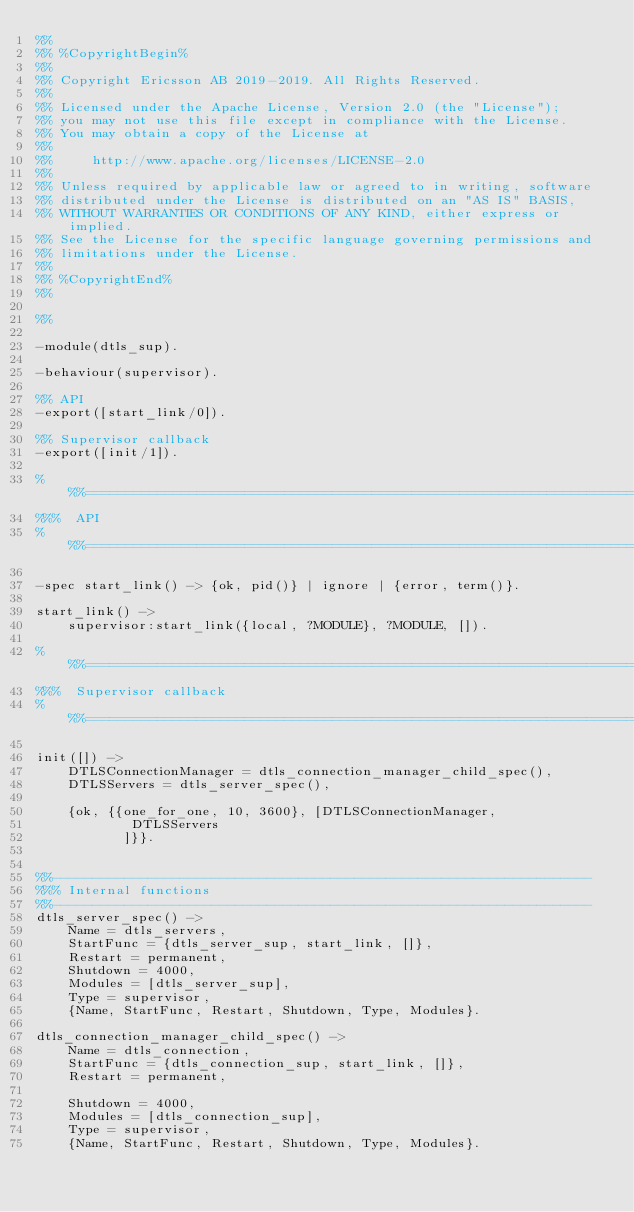Convert code to text. <code><loc_0><loc_0><loc_500><loc_500><_Erlang_>%%
%% %CopyrightBegin%
%%
%% Copyright Ericsson AB 2019-2019. All Rights Reserved.
%%
%% Licensed under the Apache License, Version 2.0 (the "License");
%% you may not use this file except in compliance with the License.
%% You may obtain a copy of the License at
%%
%%     http://www.apache.org/licenses/LICENSE-2.0
%%
%% Unless required by applicable law or agreed to in writing, software
%% distributed under the License is distributed on an "AS IS" BASIS,
%% WITHOUT WARRANTIES OR CONDITIONS OF ANY KIND, either express or implied.
%% See the License for the specific language governing permissions and
%% limitations under the License.
%%
%% %CopyrightEnd%
%%

%%

-module(dtls_sup).

-behaviour(supervisor).

%% API
-export([start_link/0]).

%% Supervisor callback
-export([init/1]).

%%%=========================================================================
%%%  API
%%%=========================================================================

-spec start_link() -> {ok, pid()} | ignore | {error, term()}.
			
start_link() ->
    supervisor:start_link({local, ?MODULE}, ?MODULE, []).

%%%=========================================================================
%%%  Supervisor callback
%%%=========================================================================

init([]) ->    
    DTLSConnectionManager = dtls_connection_manager_child_spec(),
    DTLSServers = dtls_server_spec(),
    
    {ok, {{one_for_one, 10, 3600}, [DTLSConnectionManager, 
				    DTLSServers
				   ]}}.

    
%%--------------------------------------------------------------------
%%% Internal functions
%%--------------------------------------------------------------------
dtls_server_spec() ->
    Name = dtls_servers,
    StartFunc = {dtls_server_sup, start_link, []},
    Restart = permanent,
    Shutdown = 4000,
    Modules = [dtls_server_sup],
    Type = supervisor,
    {Name, StartFunc, Restart, Shutdown, Type, Modules}.

dtls_connection_manager_child_spec() ->
    Name = dtls_connection,
    StartFunc = {dtls_connection_sup, start_link, []},
    Restart = permanent,

    Shutdown = 4000,
    Modules = [dtls_connection_sup],
    Type = supervisor,
    {Name, StartFunc, Restart, Shutdown, Type, Modules}.

</code> 